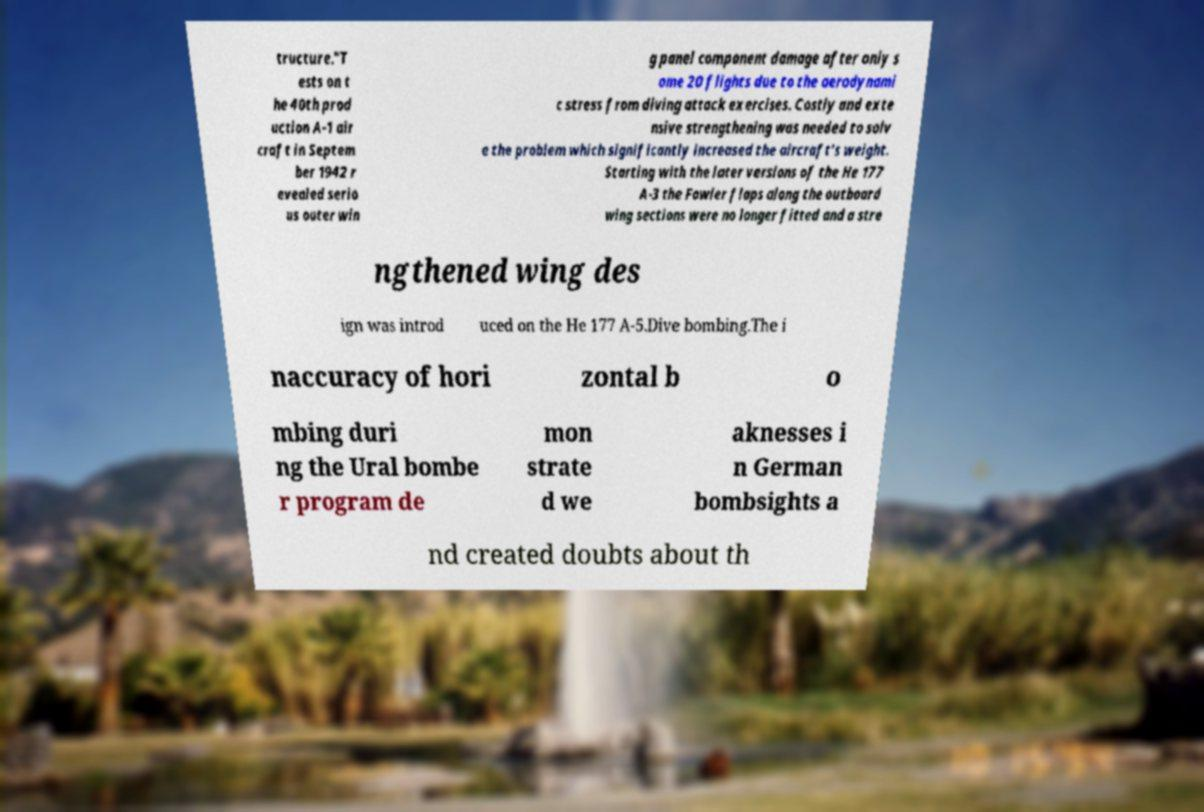Can you accurately transcribe the text from the provided image for me? tructure."T ests on t he 40th prod uction A-1 air craft in Septem ber 1942 r evealed serio us outer win g panel component damage after only s ome 20 flights due to the aerodynami c stress from diving attack exercises. Costly and exte nsive strengthening was needed to solv e the problem which significantly increased the aircraft's weight. Starting with the later versions of the He 177 A-3 the Fowler flaps along the outboard wing sections were no longer fitted and a stre ngthened wing des ign was introd uced on the He 177 A-5.Dive bombing.The i naccuracy of hori zontal b o mbing duri ng the Ural bombe r program de mon strate d we aknesses i n German bombsights a nd created doubts about th 